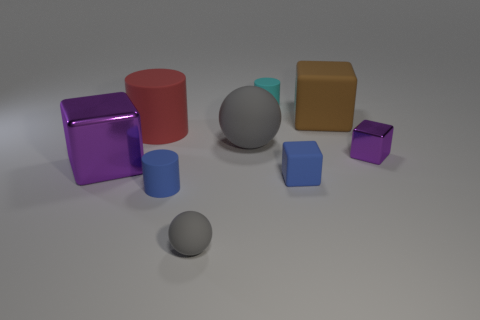Add 1 cylinders. How many objects exist? 10 Subtract all spheres. How many objects are left? 7 Add 1 large rubber cubes. How many large rubber cubes exist? 2 Subtract 0 cyan balls. How many objects are left? 9 Subtract all gray rubber balls. Subtract all red matte cylinders. How many objects are left? 6 Add 6 tiny spheres. How many tiny spheres are left? 7 